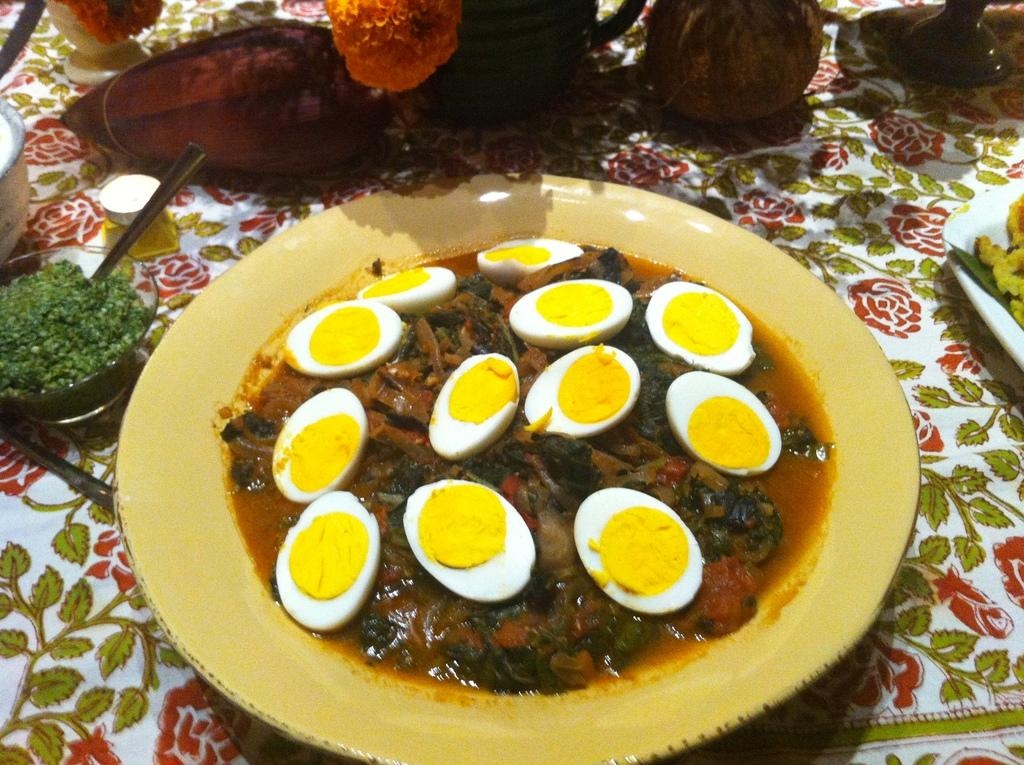What is the main subject in the middle of the image? There is food in a plate in the middle of the image. What utensil is present on the left side of the image? There is a spoon in a bowl on the left side of the image. What type of decoration can be seen at the top of the image? There are flowers visible at the top of the image. What type of laborer is working on the wave in the image? There is no laborer or wave present in the image. 